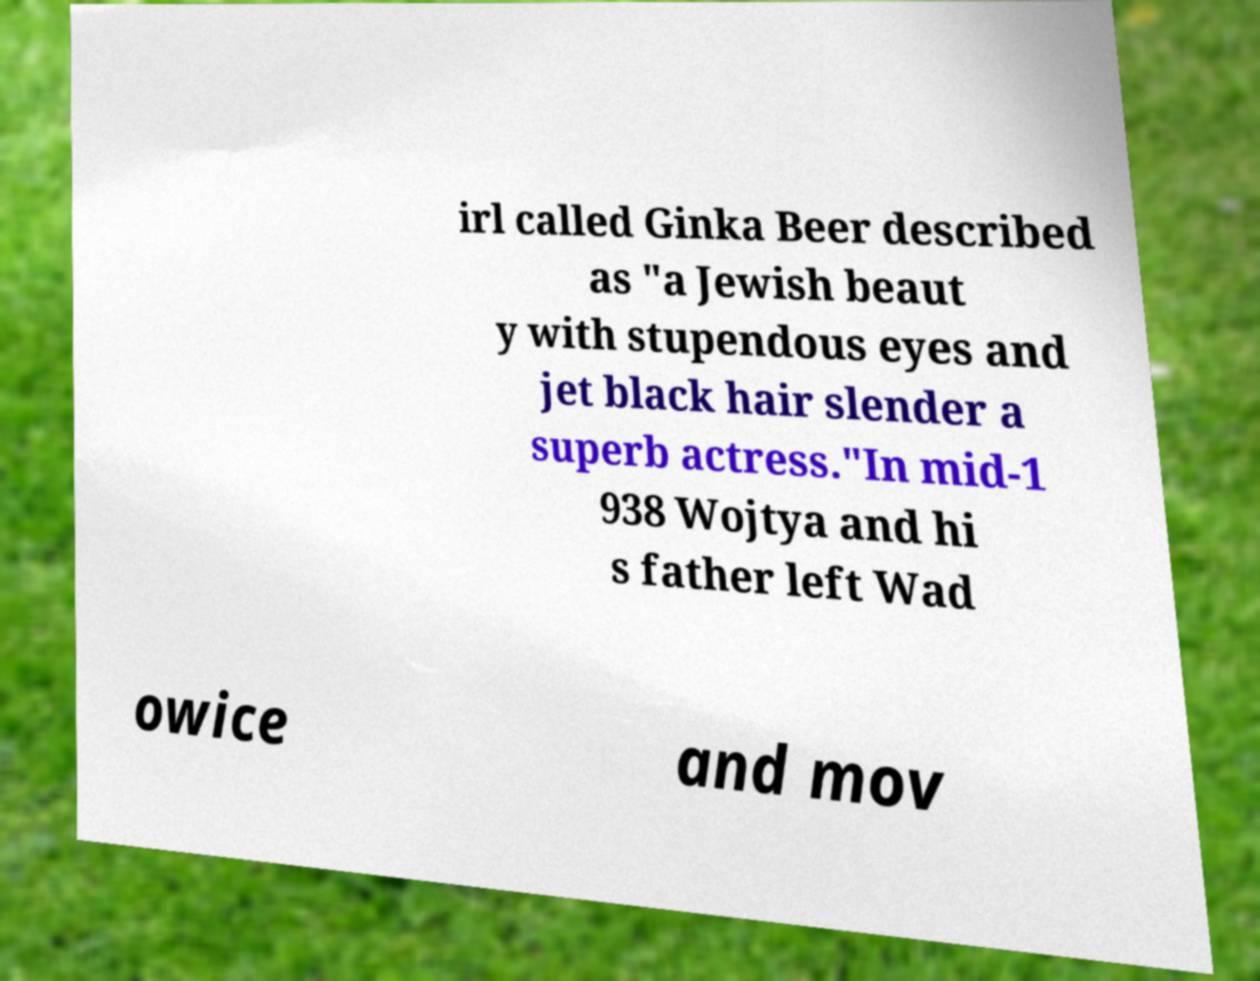Could you extract and type out the text from this image? irl called Ginka Beer described as "a Jewish beaut y with stupendous eyes and jet black hair slender a superb actress."In mid-1 938 Wojtya and hi s father left Wad owice and mov 